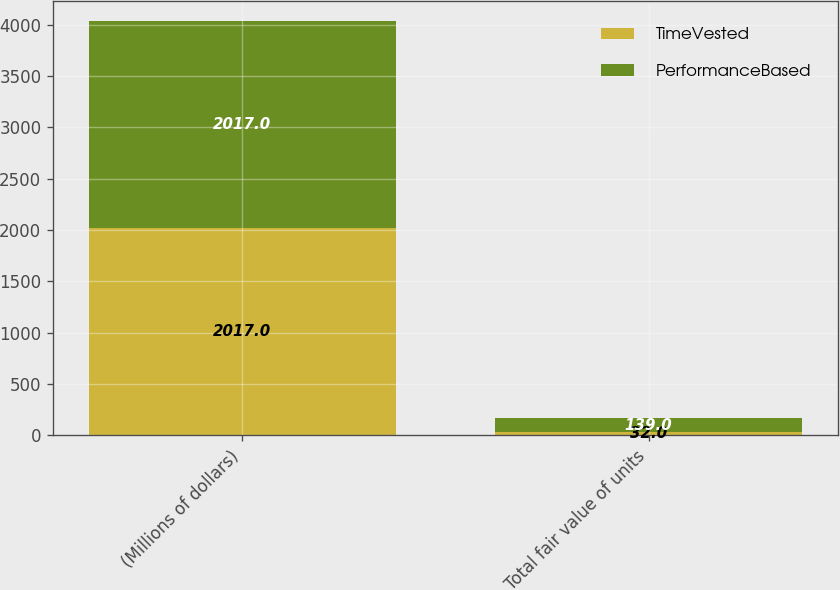<chart> <loc_0><loc_0><loc_500><loc_500><stacked_bar_chart><ecel><fcel>(Millions of dollars)<fcel>Total fair value of units<nl><fcel>TimeVested<fcel>2017<fcel>32<nl><fcel>PerformanceBased<fcel>2017<fcel>139<nl></chart> 